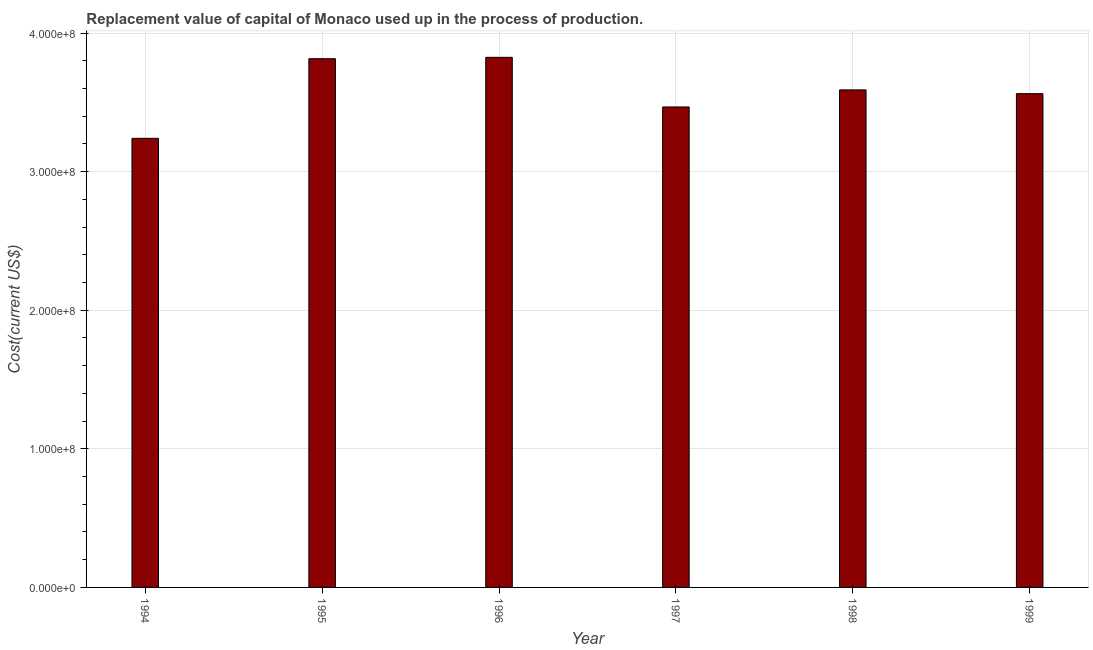What is the title of the graph?
Provide a short and direct response. Replacement value of capital of Monaco used up in the process of production. What is the label or title of the X-axis?
Offer a terse response. Year. What is the label or title of the Y-axis?
Offer a terse response. Cost(current US$). What is the consumption of fixed capital in 1996?
Give a very brief answer. 3.82e+08. Across all years, what is the maximum consumption of fixed capital?
Your response must be concise. 3.82e+08. Across all years, what is the minimum consumption of fixed capital?
Offer a terse response. 3.24e+08. In which year was the consumption of fixed capital maximum?
Your response must be concise. 1996. In which year was the consumption of fixed capital minimum?
Ensure brevity in your answer.  1994. What is the sum of the consumption of fixed capital?
Offer a terse response. 2.15e+09. What is the difference between the consumption of fixed capital in 1994 and 1995?
Your answer should be compact. -5.75e+07. What is the average consumption of fixed capital per year?
Offer a terse response. 3.58e+08. What is the median consumption of fixed capital?
Your answer should be very brief. 3.58e+08. Do a majority of the years between 1998 and 1994 (inclusive) have consumption of fixed capital greater than 300000000 US$?
Offer a terse response. Yes. What is the ratio of the consumption of fixed capital in 1995 to that in 1998?
Provide a succinct answer. 1.06. Is the difference between the consumption of fixed capital in 1995 and 1999 greater than the difference between any two years?
Provide a short and direct response. No. What is the difference between the highest and the second highest consumption of fixed capital?
Offer a very short reply. 9.97e+05. Is the sum of the consumption of fixed capital in 1995 and 1997 greater than the maximum consumption of fixed capital across all years?
Make the answer very short. Yes. What is the difference between the highest and the lowest consumption of fixed capital?
Make the answer very short. 5.85e+07. Are all the bars in the graph horizontal?
Your answer should be compact. No. What is the difference between two consecutive major ticks on the Y-axis?
Your answer should be compact. 1.00e+08. Are the values on the major ticks of Y-axis written in scientific E-notation?
Keep it short and to the point. Yes. What is the Cost(current US$) of 1994?
Provide a short and direct response. 3.24e+08. What is the Cost(current US$) of 1995?
Make the answer very short. 3.81e+08. What is the Cost(current US$) of 1996?
Offer a terse response. 3.82e+08. What is the Cost(current US$) of 1997?
Give a very brief answer. 3.47e+08. What is the Cost(current US$) of 1998?
Offer a terse response. 3.59e+08. What is the Cost(current US$) in 1999?
Provide a short and direct response. 3.56e+08. What is the difference between the Cost(current US$) in 1994 and 1995?
Provide a succinct answer. -5.75e+07. What is the difference between the Cost(current US$) in 1994 and 1996?
Give a very brief answer. -5.85e+07. What is the difference between the Cost(current US$) in 1994 and 1997?
Offer a very short reply. -2.26e+07. What is the difference between the Cost(current US$) in 1994 and 1998?
Offer a very short reply. -3.50e+07. What is the difference between the Cost(current US$) in 1994 and 1999?
Your answer should be very brief. -3.22e+07. What is the difference between the Cost(current US$) in 1995 and 1996?
Ensure brevity in your answer.  -9.97e+05. What is the difference between the Cost(current US$) in 1995 and 1997?
Your answer should be compact. 3.48e+07. What is the difference between the Cost(current US$) in 1995 and 1998?
Make the answer very short. 2.25e+07. What is the difference between the Cost(current US$) in 1995 and 1999?
Provide a short and direct response. 2.52e+07. What is the difference between the Cost(current US$) in 1996 and 1997?
Your answer should be compact. 3.58e+07. What is the difference between the Cost(current US$) in 1996 and 1998?
Ensure brevity in your answer.  2.35e+07. What is the difference between the Cost(current US$) in 1996 and 1999?
Make the answer very short. 2.62e+07. What is the difference between the Cost(current US$) in 1997 and 1998?
Provide a short and direct response. -1.23e+07. What is the difference between the Cost(current US$) in 1997 and 1999?
Provide a succinct answer. -9.60e+06. What is the difference between the Cost(current US$) in 1998 and 1999?
Keep it short and to the point. 2.71e+06. What is the ratio of the Cost(current US$) in 1994 to that in 1995?
Provide a short and direct response. 0.85. What is the ratio of the Cost(current US$) in 1994 to that in 1996?
Provide a succinct answer. 0.85. What is the ratio of the Cost(current US$) in 1994 to that in 1997?
Provide a short and direct response. 0.94. What is the ratio of the Cost(current US$) in 1994 to that in 1998?
Keep it short and to the point. 0.9. What is the ratio of the Cost(current US$) in 1994 to that in 1999?
Offer a terse response. 0.91. What is the ratio of the Cost(current US$) in 1995 to that in 1996?
Your response must be concise. 1. What is the ratio of the Cost(current US$) in 1995 to that in 1998?
Offer a terse response. 1.06. What is the ratio of the Cost(current US$) in 1995 to that in 1999?
Your answer should be compact. 1.07. What is the ratio of the Cost(current US$) in 1996 to that in 1997?
Ensure brevity in your answer.  1.1. What is the ratio of the Cost(current US$) in 1996 to that in 1998?
Offer a terse response. 1.06. What is the ratio of the Cost(current US$) in 1996 to that in 1999?
Make the answer very short. 1.07. What is the ratio of the Cost(current US$) in 1998 to that in 1999?
Provide a succinct answer. 1.01. 